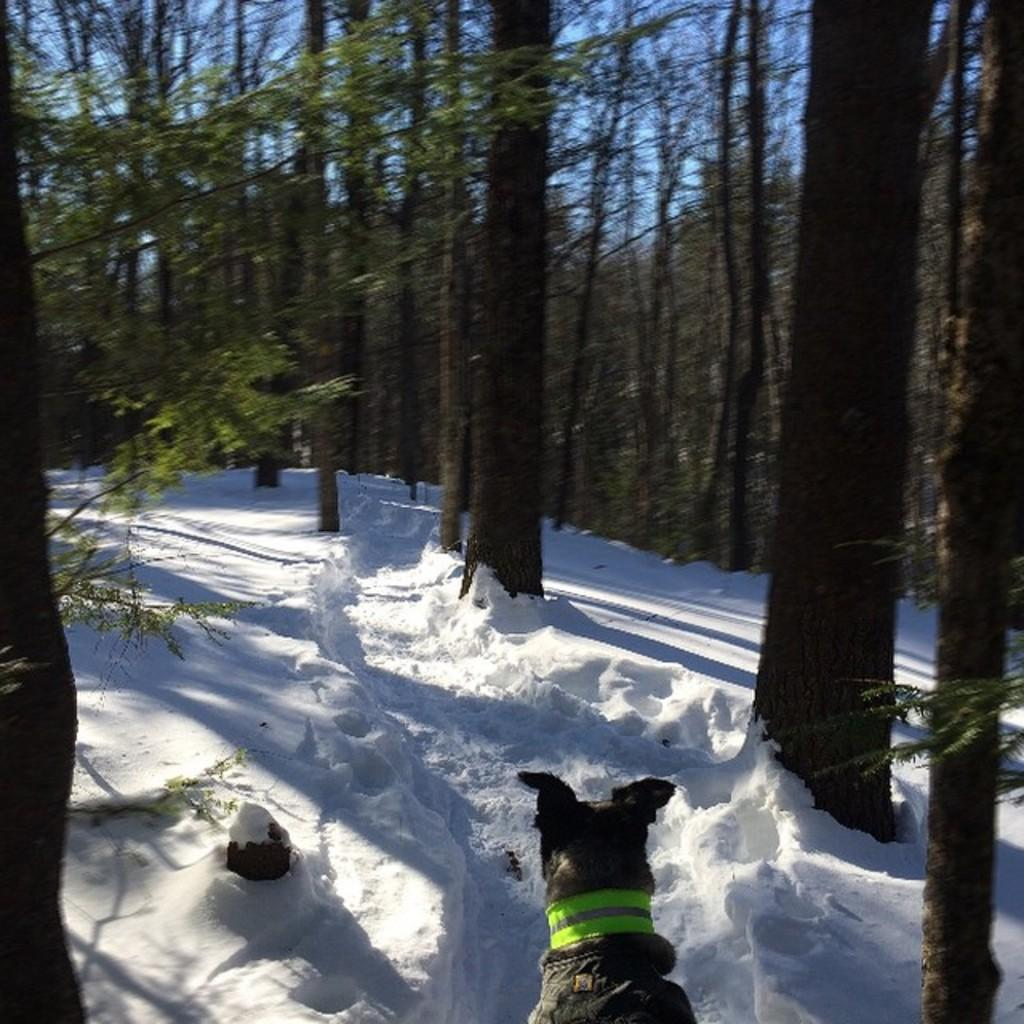What animal is present in the image? There is a dog in the image. What is the environment in which the dog is situated? The dog is in the snow. What type of vegetation can be seen in the image? There are trees visible in the image. What type of current is flowing through the pot in the image? There is no pot or current present in the image; it features a dog in the snow with trees in the background. 